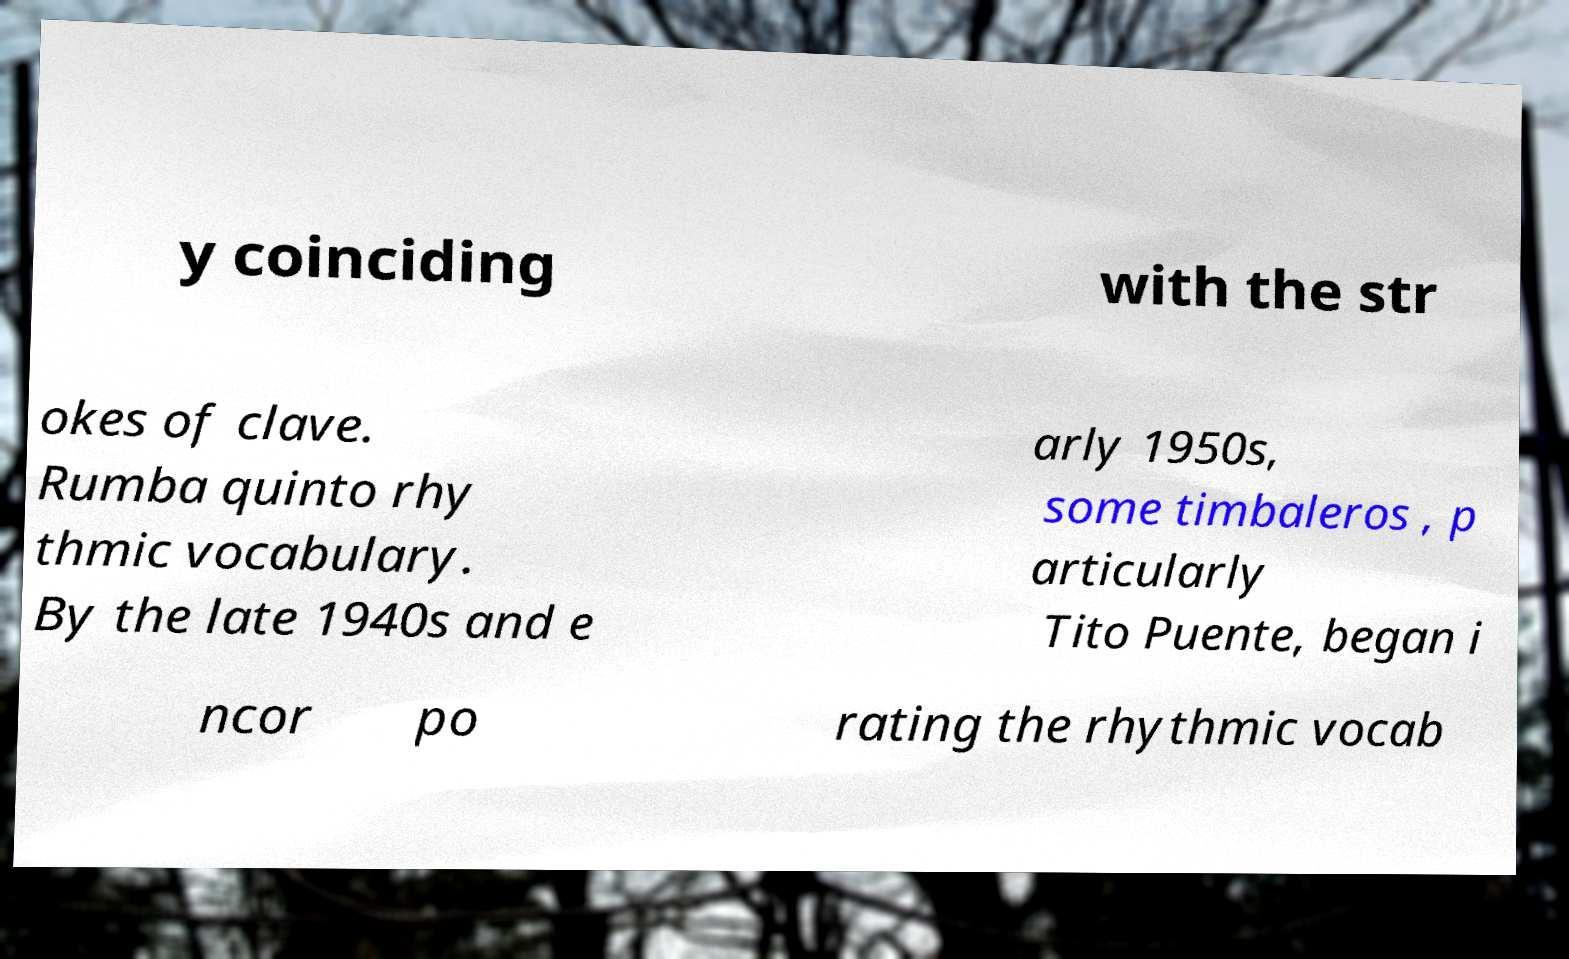Could you extract and type out the text from this image? y coinciding with the str okes of clave. Rumba quinto rhy thmic vocabulary. By the late 1940s and e arly 1950s, some timbaleros , p articularly Tito Puente, began i ncor po rating the rhythmic vocab 